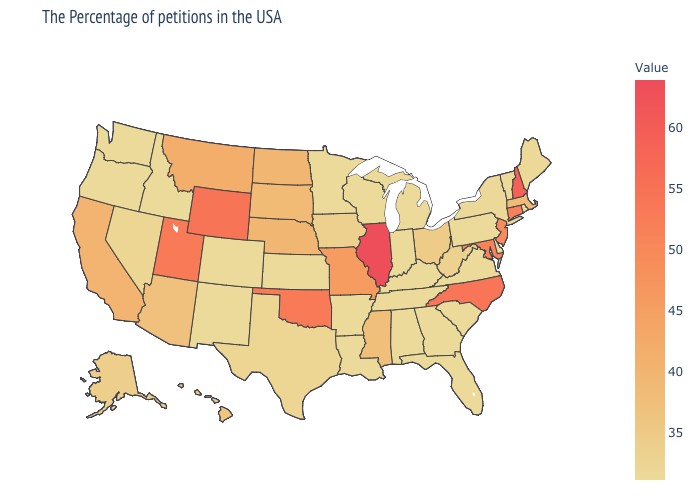Which states have the lowest value in the MidWest?
Be succinct. Michigan, Indiana, Wisconsin, Minnesota, Kansas. Does Louisiana have the lowest value in the South?
Short answer required. Yes. Does Texas have the highest value in the USA?
Write a very short answer. No. Does North Dakota have the highest value in the MidWest?
Quick response, please. No. Does Utah have the lowest value in the West?
Give a very brief answer. No. Does Colorado have a lower value than Wyoming?
Quick response, please. Yes. Among the states that border Louisiana , which have the highest value?
Give a very brief answer. Mississippi. Does Vermont have the lowest value in the USA?
Be succinct. Yes. 